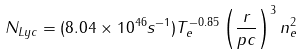<formula> <loc_0><loc_0><loc_500><loc_500>N _ { L y c } = ( 8 . 0 4 \times 1 0 ^ { 4 6 } s ^ { - 1 } ) T _ { e } ^ { - 0 . 8 5 } \left ( \frac { r } { p c } \right ) ^ { 3 } n _ { e } ^ { 2 }</formula> 